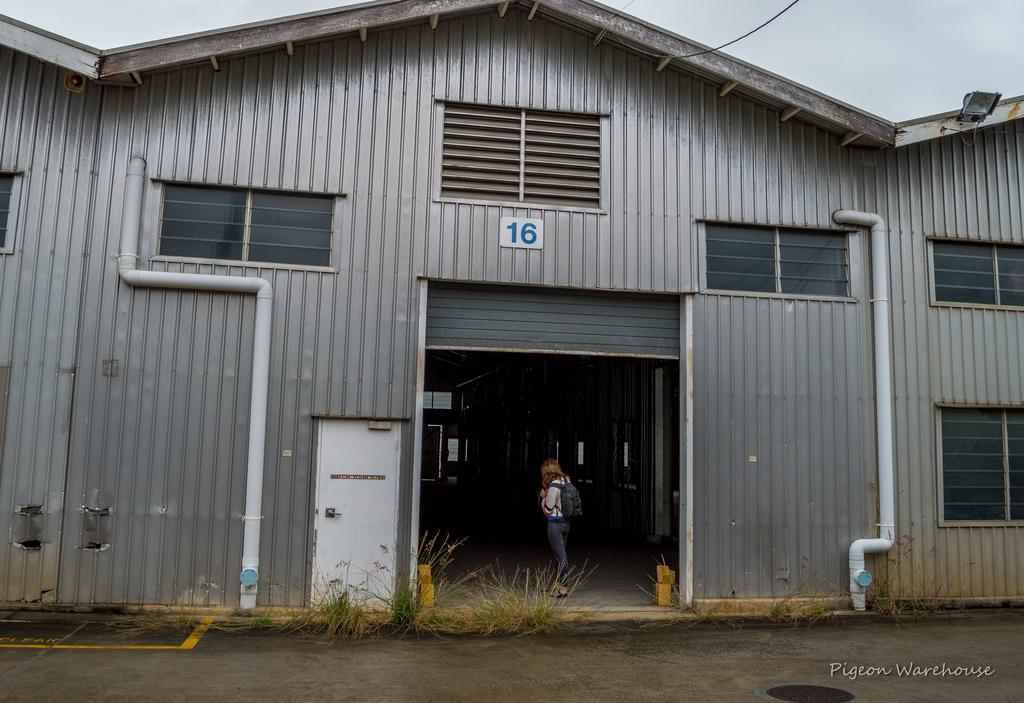What is inside the shed in the image? There is a person in the shed. What can be seen on the walls or surfaces in the shed? There is a text label in the shed. What is providing illumination in the shed? There are lights in the shed. How can natural light enter the shed? There are windows in the shed. What is present for plumbing purposes in the shed? There are pipes in the shed. How can one enter or exit the shed? There are doors in the shed. What type of vegetation is visible in the image? There is grass and plants visible in the image. What is visible in the background of the image? The sky and the ground are visible in the image. What type of quartz can be seen on the person's wrist in the image? There is no quartz visible on the person's wrist in the image. What word is the frog saying in the image? There are no frogs present in the image, so it is not possible to determine what a frog might be saying. 